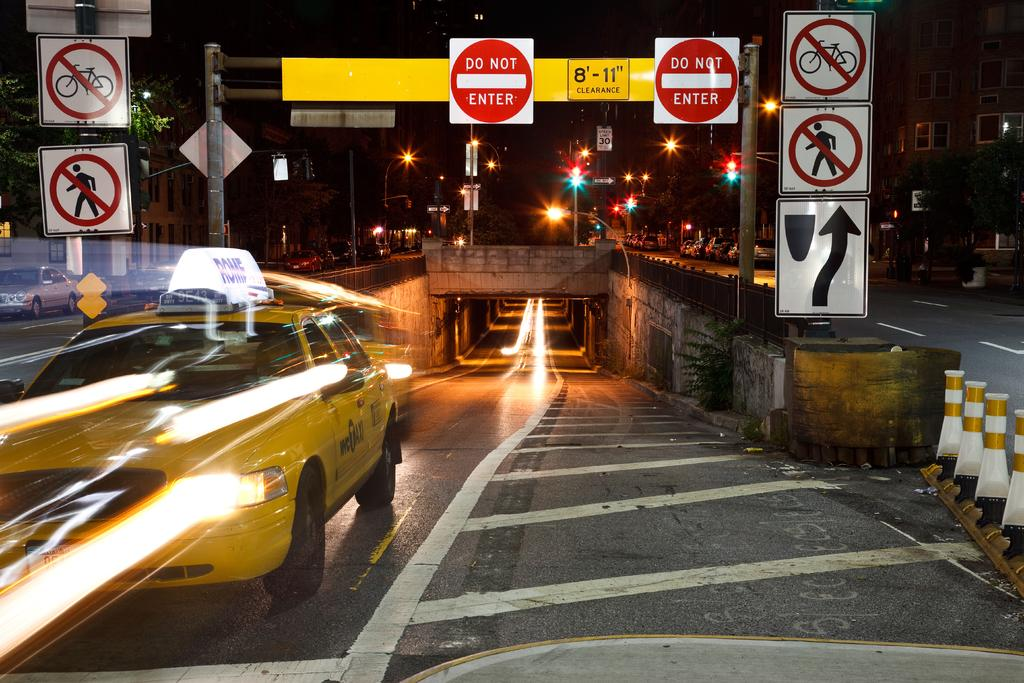Provide a one-sentence caption for the provided image. Road signs with two of them being DO NOT ENTER signs. 